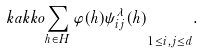<formula> <loc_0><loc_0><loc_500><loc_500>\ k a k k o { \sum _ { h \in H } \varphi ( h ) \psi ^ { \lambda } _ { i j } ( h ) } _ { 1 \leq i , j \leq d } .</formula> 